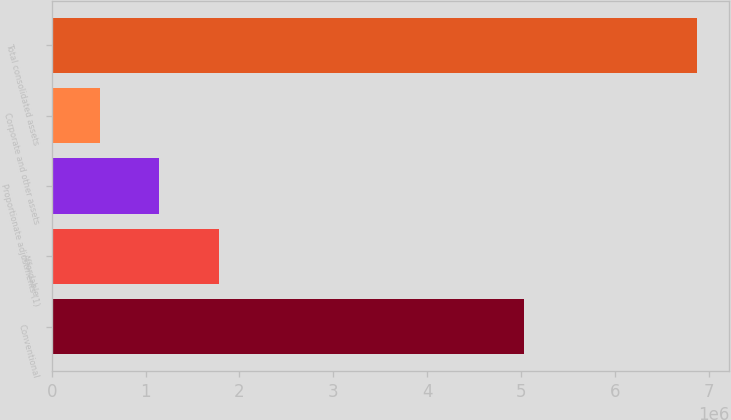Convert chart to OTSL. <chart><loc_0><loc_0><loc_500><loc_500><bar_chart><fcel>Conventional<fcel>Affordable<fcel>Proportionate adjustments (1)<fcel>Corporate and other assets<fcel>Total consolidated assets<nl><fcel>5.03186e+06<fcel>1.78342e+06<fcel>1.14736e+06<fcel>511306<fcel>6.87186e+06<nl></chart> 